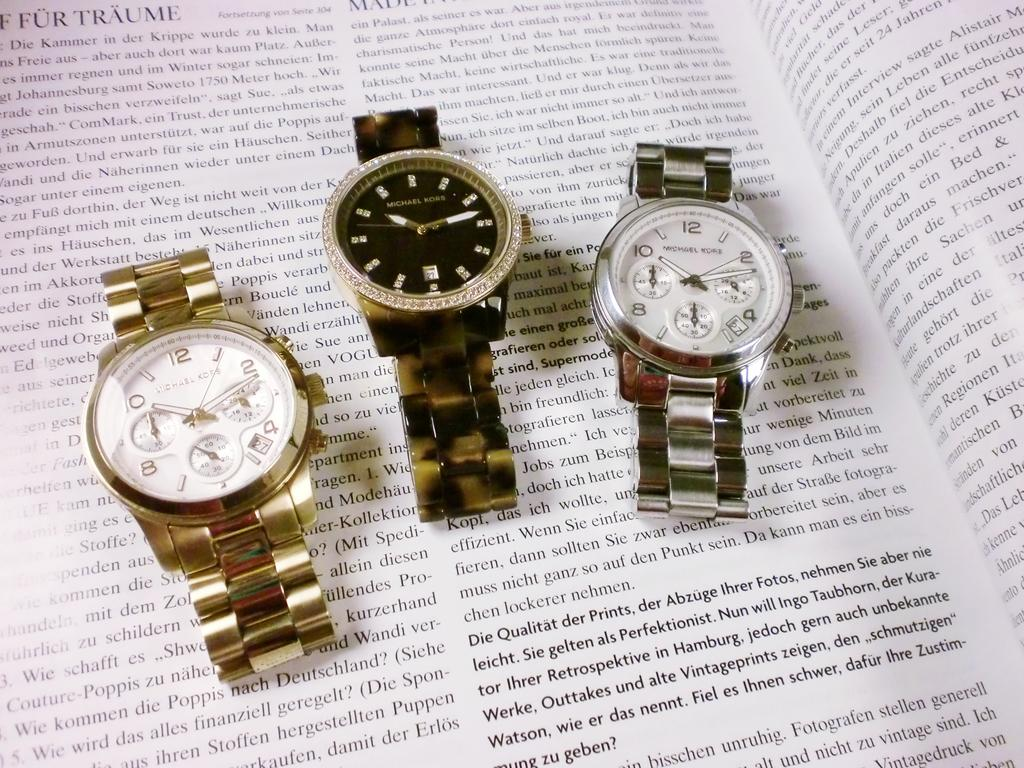<image>
Present a compact description of the photo's key features. Three Michael Kors watch's sit on top of book in german 